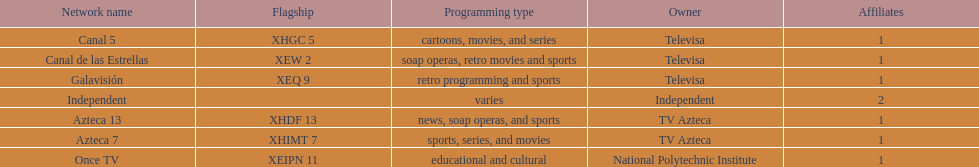What is the total number of affiliates among all the networks? 8. 